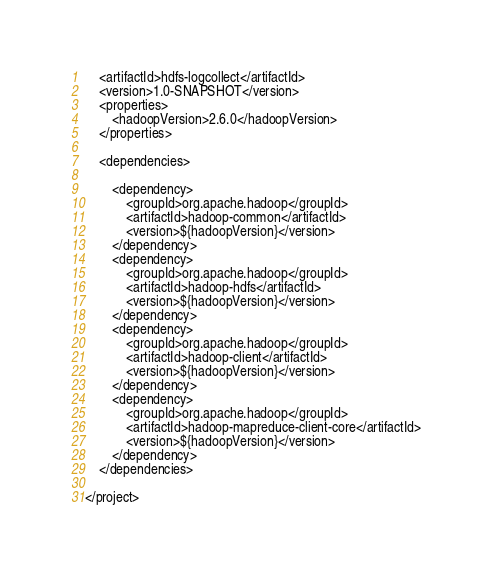Convert code to text. <code><loc_0><loc_0><loc_500><loc_500><_XML_>    <artifactId>hdfs-logcollect</artifactId>
    <version>1.0-SNAPSHOT</version>
    <properties>
        <hadoopVersion>2.6.0</hadoopVersion>
    </properties>

    <dependencies>

        <dependency>
            <groupId>org.apache.hadoop</groupId>
            <artifactId>hadoop-common</artifactId>
            <version>${hadoopVersion}</version>
        </dependency>
        <dependency>
            <groupId>org.apache.hadoop</groupId>
            <artifactId>hadoop-hdfs</artifactId>
            <version>${hadoopVersion}</version>
        </dependency>
        <dependency>
            <groupId>org.apache.hadoop</groupId>
            <artifactId>hadoop-client</artifactId>
            <version>${hadoopVersion}</version>
        </dependency>
        <dependency>
            <groupId>org.apache.hadoop</groupId>
            <artifactId>hadoop-mapreduce-client-core</artifactId>
            <version>${hadoopVersion}</version>
        </dependency>
    </dependencies>

</project></code> 